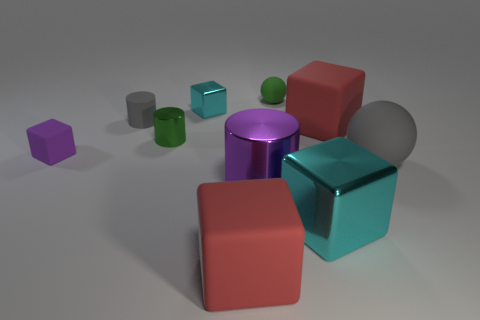Subtract all cyan cylinders. How many red blocks are left? 2 Subtract all small cylinders. How many cylinders are left? 1 Subtract all purple blocks. How many blocks are left? 4 Subtract 1 blocks. How many blocks are left? 4 Subtract all gray cubes. Subtract all blue spheres. How many cubes are left? 5 Subtract all spheres. How many objects are left? 8 Subtract all cyan blocks. Subtract all red rubber objects. How many objects are left? 6 Add 7 small green balls. How many small green balls are left? 8 Add 4 gray cylinders. How many gray cylinders exist? 5 Subtract 0 brown spheres. How many objects are left? 10 